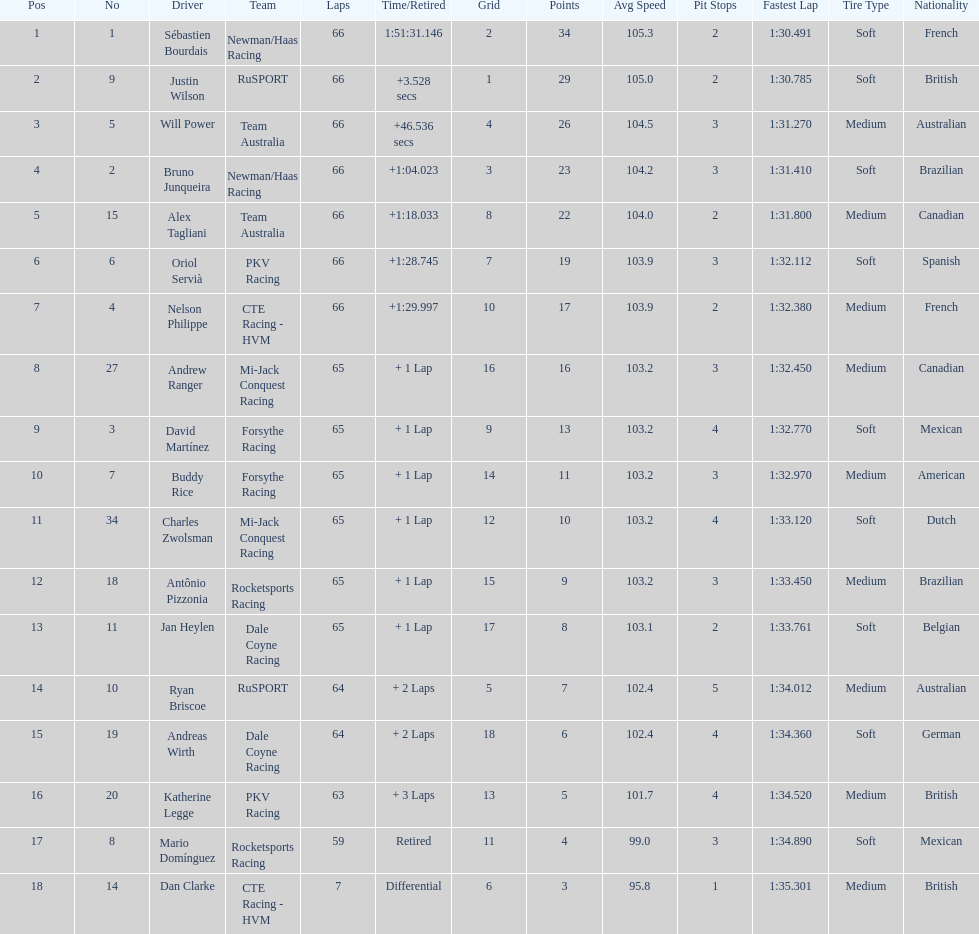What is the number of laps dan clarke completed? 7. 